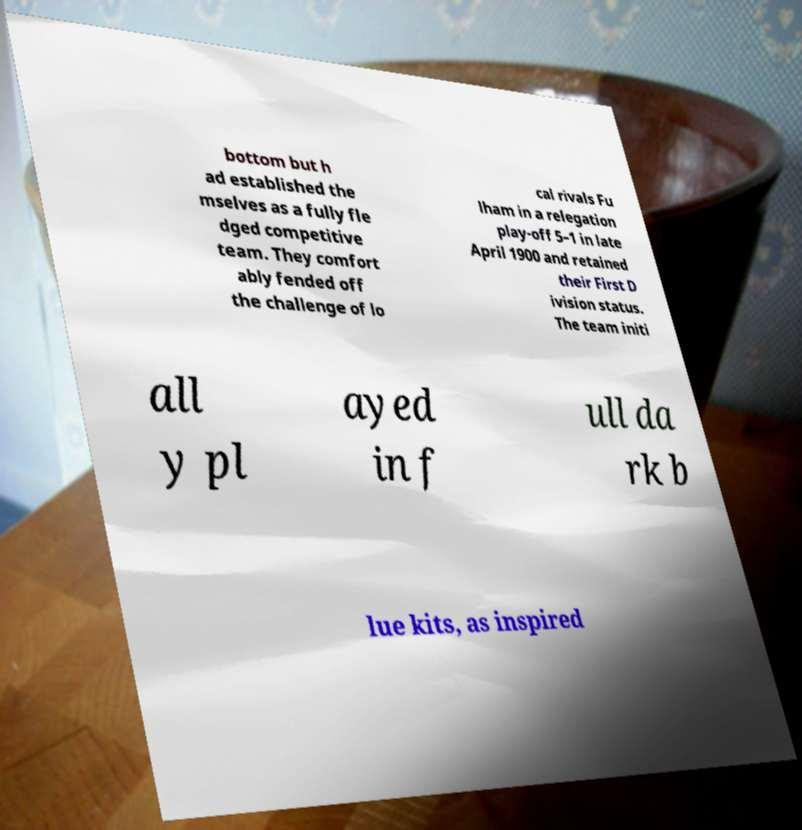Please read and relay the text visible in this image. What does it say? bottom but h ad established the mselves as a fully fle dged competitive team. They comfort ably fended off the challenge of lo cal rivals Fu lham in a relegation play-off 5–1 in late April 1900 and retained their First D ivision status. The team initi all y pl ayed in f ull da rk b lue kits, as inspired 